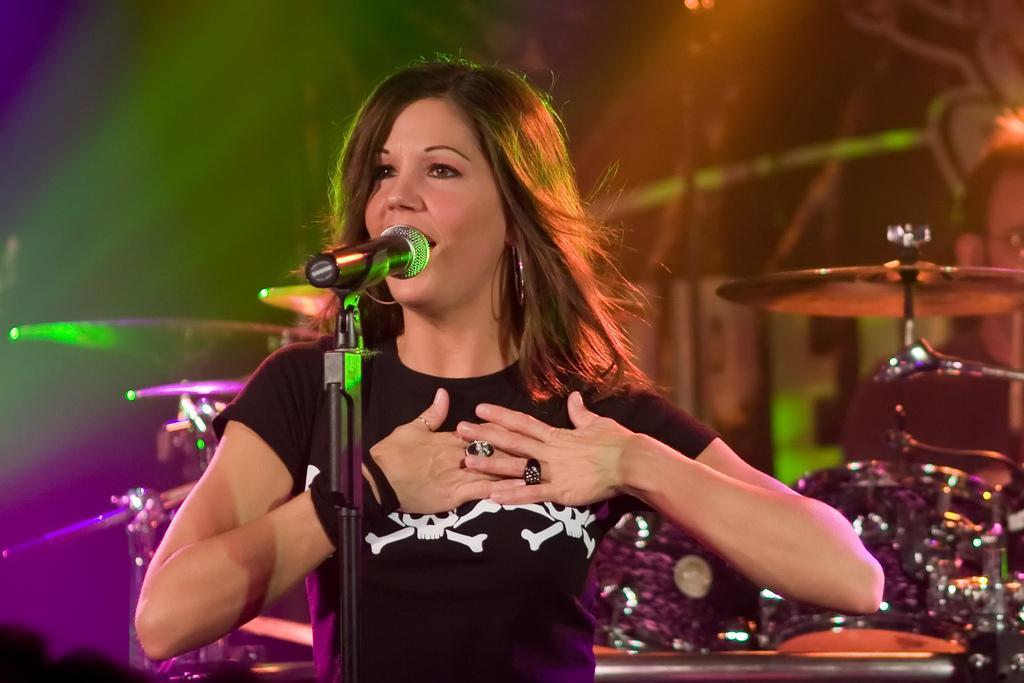Can you describe this image briefly? In this picture we can see a woman in the black t shirt and in front of the woman there is a microphone with stand. Behind the woman there are some musical instruments, and this looks like a person. Behind the people there are some colorful lights. 